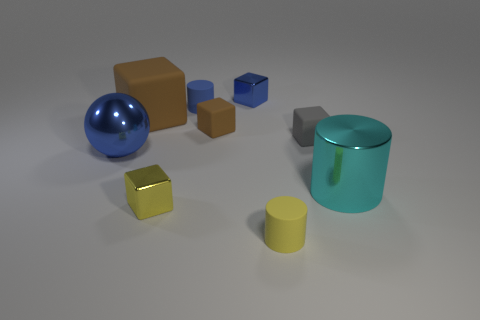What is the size of the blue thing that is both on the left side of the tiny blue metal cube and to the right of the shiny sphere?
Ensure brevity in your answer.  Small. What number of metal things are blue objects or large blue things?
Make the answer very short. 2. What is the material of the big brown object?
Keep it short and to the point. Rubber. What material is the big object that is right of the metal block that is in front of the big shiny thing behind the big cyan object made of?
Provide a succinct answer. Metal. The yellow rubber thing that is the same size as the blue cylinder is what shape?
Provide a short and direct response. Cylinder. What number of things are small cyan things or small yellow things in front of the small yellow shiny block?
Offer a terse response. 1. Do the small blue thing that is on the left side of the small blue shiny block and the yellow cube in front of the metal cylinder have the same material?
Your answer should be very brief. No. There is a rubber thing that is the same color as the large sphere; what is its shape?
Offer a terse response. Cylinder. How many purple things are rubber cubes or small matte objects?
Give a very brief answer. 0. The blue cylinder has what size?
Keep it short and to the point. Small. 